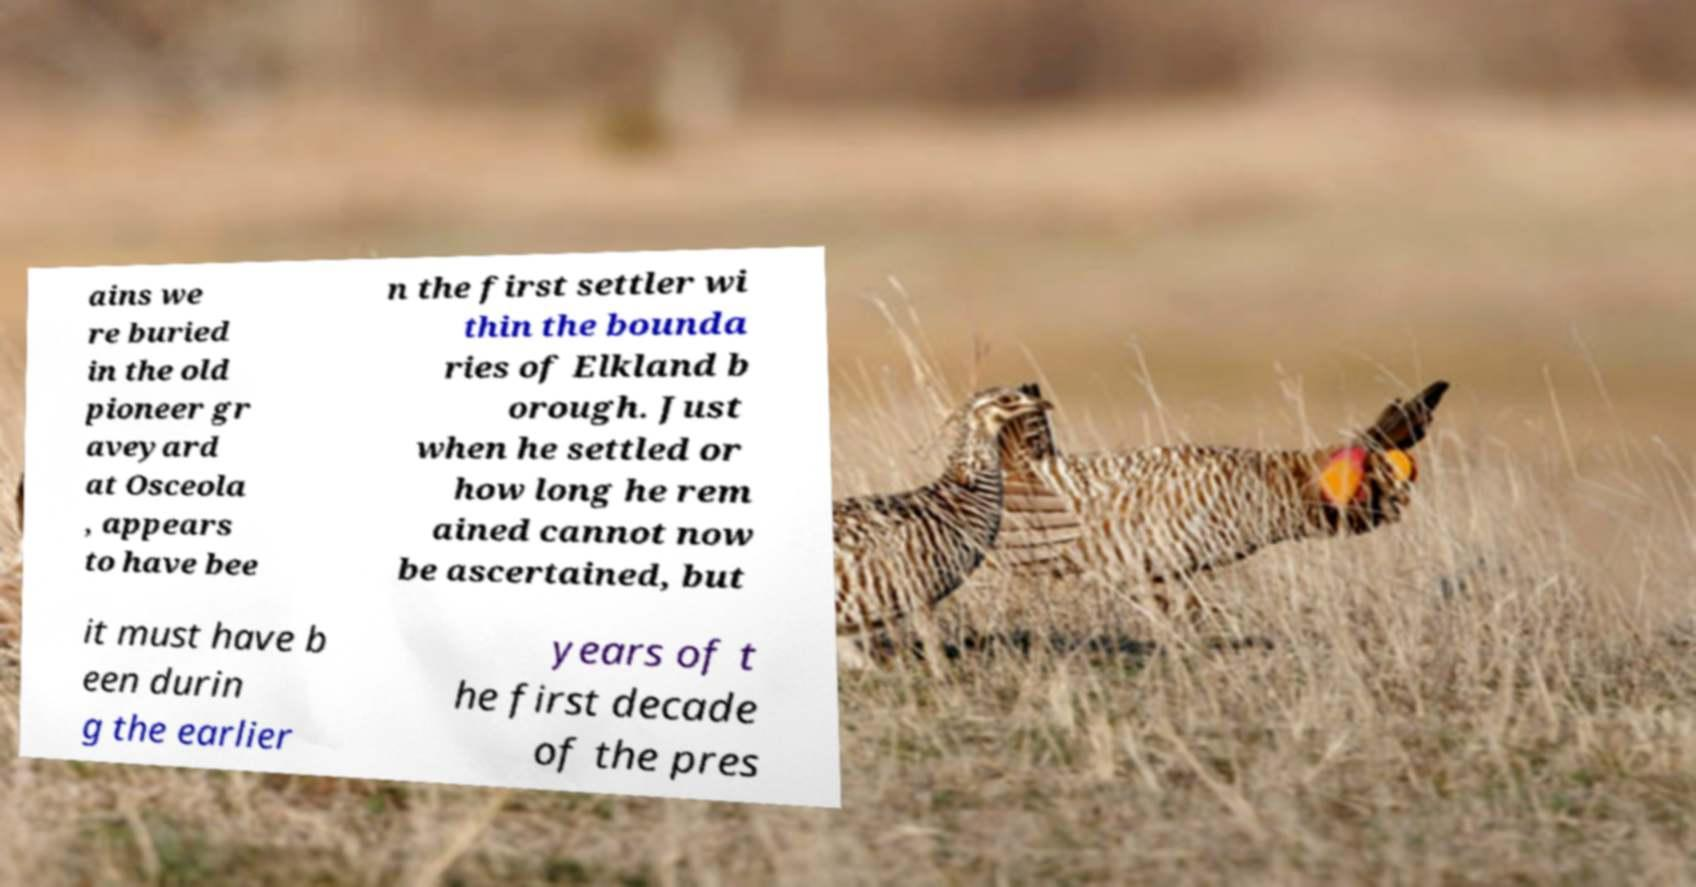Can you accurately transcribe the text from the provided image for me? ains we re buried in the old pioneer gr aveyard at Osceola , appears to have bee n the first settler wi thin the bounda ries of Elkland b orough. Just when he settled or how long he rem ained cannot now be ascertained, but it must have b een durin g the earlier years of t he first decade of the pres 